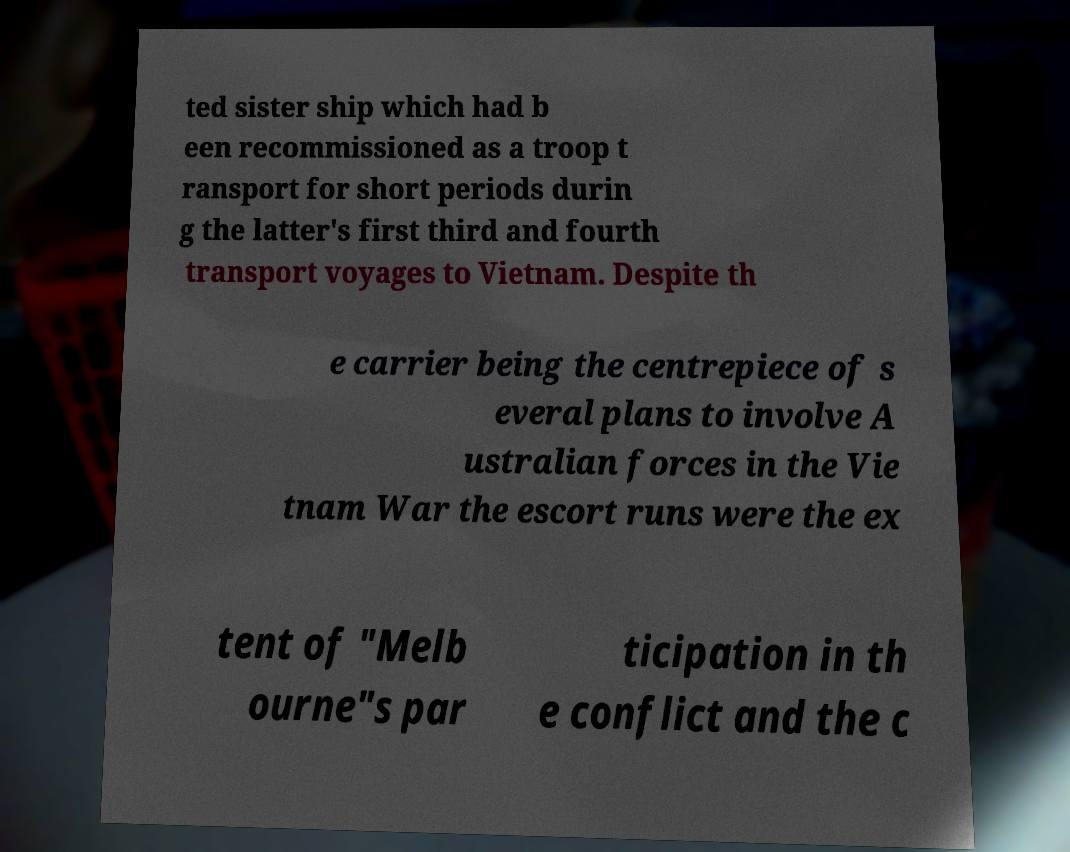Could you extract and type out the text from this image? ted sister ship which had b een recommissioned as a troop t ransport for short periods durin g the latter's first third and fourth transport voyages to Vietnam. Despite th e carrier being the centrepiece of s everal plans to involve A ustralian forces in the Vie tnam War the escort runs were the ex tent of "Melb ourne"s par ticipation in th e conflict and the c 